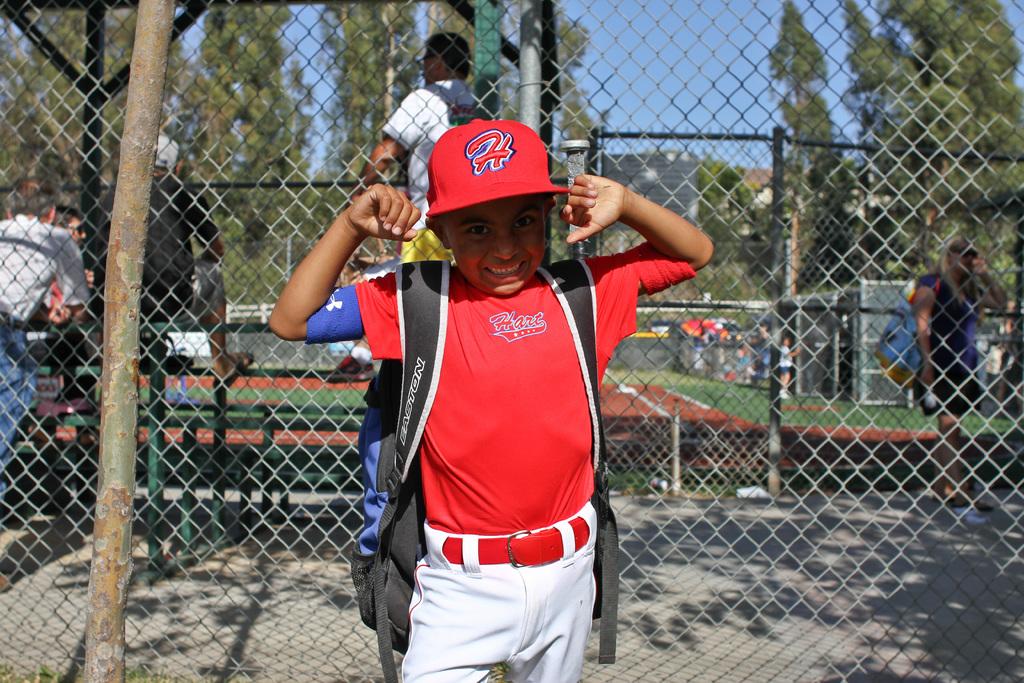What is the name on his shirt?
Give a very brief answer. Hart. 